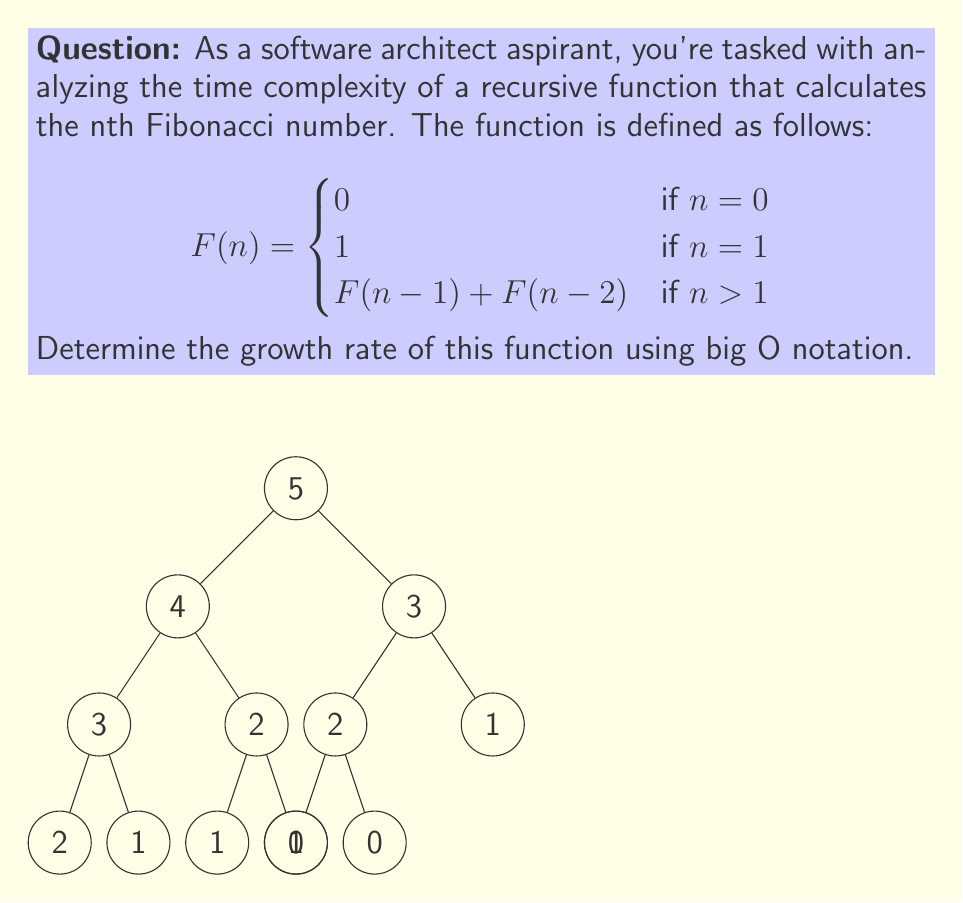Can you solve this math problem? To analyze the growth rate of this recursive Fibonacci function, we need to consider the number of function calls made for each input n.

1) Base cases:
   For n = 0 or n = 1, the function returns immediately with O(1) time complexity.

2) Recursive case:
   For n > 1, the function makes two recursive calls: F(n-1) and F(n-2).

3) Recurrence relation:
   Let T(n) be the number of function calls for input n.
   T(n) = T(n-1) + T(n-2) + 1, where the +1 accounts for the current function call.

4) Solving the recurrence relation:
   The solution to this recurrence is closely related to the Fibonacci sequence itself.
   It can be shown that T(n) is approximately proportional to $\phi^n$, where $\phi = \frac{1 + \sqrt{5}}{2}$ is the golden ratio.

5) Asymptotic growth:
   Since $\phi^n$ grows exponentially, we can express the time complexity as O($2^n$).
   More precisely, it's O($\phi^n$), but in big O notation, we typically use 2 as the base for exponential functions.

6) Comparison with exact Fibonacci values:
   The exact number of function calls is less than $2^n$ for all n, but it grows exponentially at a rate of approximately $1.6^n$.

7) Space complexity:
   The space complexity is O(n) due to the maximum depth of the recursion tree.

Therefore, the time complexity of this recursive Fibonacci function is O($2^n$), which represents exponential growth.
Answer: O($2^n$) 